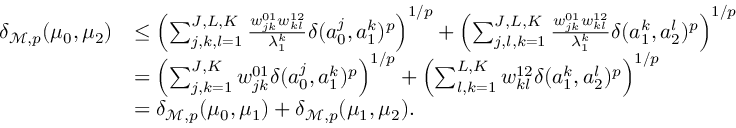Convert formula to latex. <formula><loc_0><loc_0><loc_500><loc_500>\begin{array} { r l } { \delta _ { \mathcal { M } , p } ( \mu _ { 0 } , \mu _ { 2 } ) } & { \leq \left ( \sum _ { j , k , l = 1 } ^ { J , L , K } \frac { w _ { j k } ^ { 0 1 } w _ { k l } ^ { 1 2 } } { \lambda _ { 1 } ^ { k } } \delta ( a _ { 0 } ^ { j } , a _ { 1 } ^ { k } ) ^ { p } \right ) ^ { 1 / p } + \left ( \sum _ { j , l , k = 1 } ^ { J , L , K } \frac { w _ { j k } ^ { 0 1 } w _ { k l } ^ { 1 2 } } { \lambda _ { 1 } ^ { k } } \delta ( a _ { 1 } ^ { k } , a _ { 2 } ^ { l } ) ^ { p } \right ) ^ { 1 / p } } \\ & { = \left ( \sum _ { j , k = 1 } ^ { J , K } w _ { j k } ^ { 0 1 } \delta ( a _ { 0 } ^ { j } , a _ { 1 } ^ { k } ) ^ { p } \right ) ^ { 1 / p } + \left ( \sum _ { l , k = 1 } ^ { L , K } w _ { k l } ^ { 1 2 } \delta ( a _ { 1 } ^ { k } , a _ { 2 } ^ { l } ) ^ { p } \right ) ^ { 1 / p } } \\ & { = \delta _ { \mathcal { M } , p } ( \mu _ { 0 } , \mu _ { 1 } ) + \delta _ { \mathcal { M } , p } ( \mu _ { 1 } , \mu _ { 2 } ) . } \end{array}</formula> 